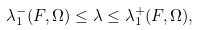<formula> <loc_0><loc_0><loc_500><loc_500>\lambda _ { 1 } ^ { - } ( F , \Omega ) \leq \lambda \leq \lambda _ { 1 } ^ { + } ( F , \Omega ) ,</formula> 